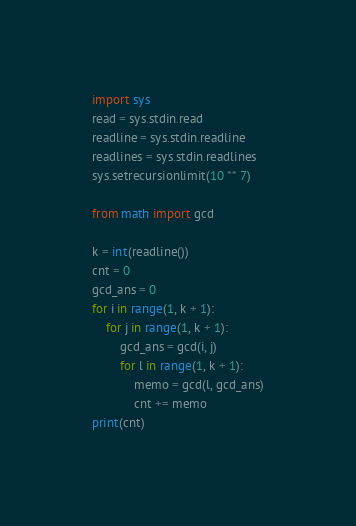<code> <loc_0><loc_0><loc_500><loc_500><_Python_>import sys
read = sys.stdin.read
readline = sys.stdin.readline
readlines = sys.stdin.readlines
sys.setrecursionlimit(10 ** 7)

from math import gcd

k = int(readline())
cnt = 0
gcd_ans = 0
for i in range(1, k + 1):
    for j in range(1, k + 1):
        gcd_ans = gcd(i, j)
        for l in range(1, k + 1):
            memo = gcd(l, gcd_ans)
            cnt += memo
print(cnt)
</code> 